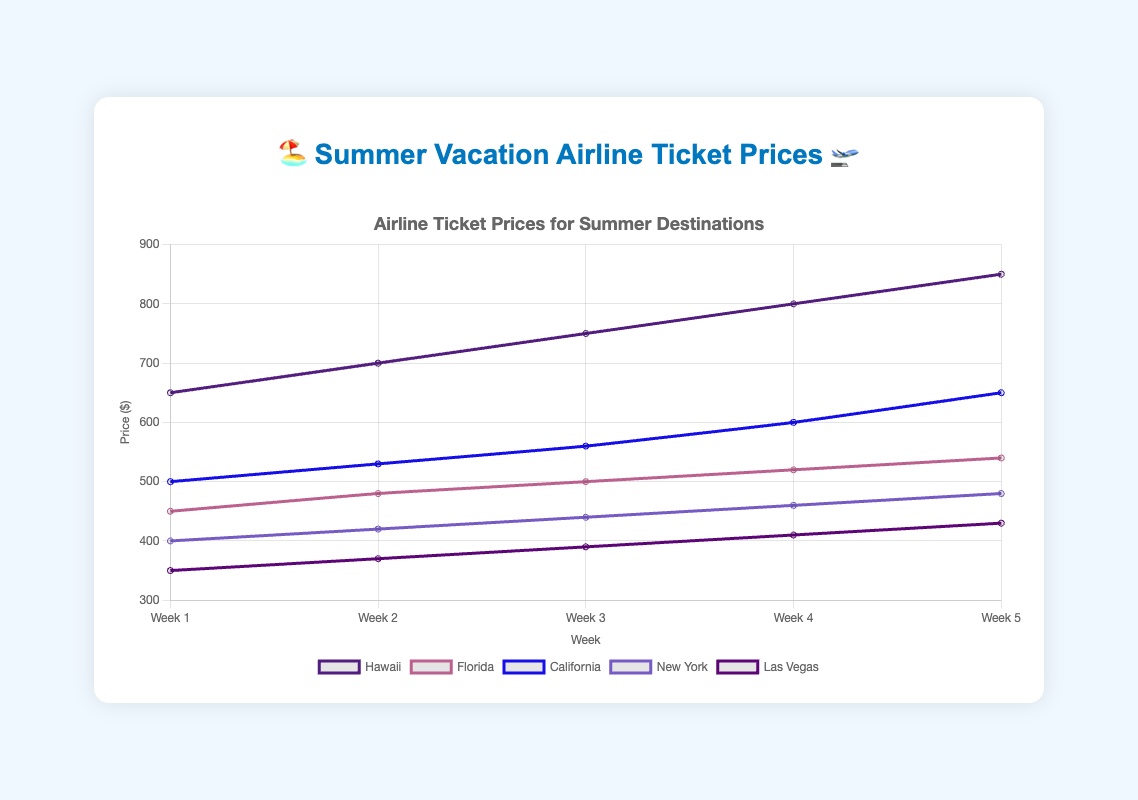What is the starting price for a ticket to Las Vegas in Week 1? The figure shows the price of tickets per week, and the price for Las Vegas in Week 1 is listed at the beginning of its line.
Answer: 350 How does the price of a ticket to Hawaii change from Week 1 to Week 5? Starting from Week 1 to Week 5, examine the line corresponding to Hawaii on the figure. The price increases progressively: Week 1 (650), Week 2 (700), Week 3 (750), Week 4 (800), Week 5 (850).
Answer: Increases Which destination has the highest ticket price in Week 5? Look at the ticket prices for all destinations in Week 5. Compare the values: Hawaii (850), Florida (540), California (650), New York (480), Las Vegas (430).
Answer: Hawaii Compare the difference in price between Florida and California in Week 3. In Week 3, the price for Florida is 500 and for California is 560. The difference is calculated as 560 - 500.
Answer: 60 Which destination has the steepest price increase from Week 1 to Week 5? Calculate the price change for each destination: 
Hawaii (850-650 = 200), Florida (540-450 = 90), California (650-500 = 150), New York (480-400 = 80), Las Vegas (430-350 = 80). Hawaii shows the most significant increase.
Answer: Hawaii Calculate the average price for a ticket to New York over the 5 weeks. Sum the prices for New York (400 + 420 + 440 + 460 + 480) which equals 2200. Divide by the number of weeks (5). 2200 / 5 gives the average price.
Answer: 440 Which two destinations have the closest ticket prices in Week 4? Compare prices for all destinations in Week 4: Hawaii (800), Florida (520), California (600), New York (460), Las Vegas (410). The closest prices are California (600) and Florida (520) with a difference of 80.
Answer: California and Florida What visual cue indicates that ticket prices are increasing for all destinations? Look at the trajectory of the lines representing each destination; all lines are trending upwards from Week 1 to Week 5.
Answer: Upward trending lines How much more expensive are tickets to Hawaii compared to New York in Week 2? Ticket prices in Week 2 for Hawaii (700) and New York (420). Calculate the difference by subtracting: 700 - 420.
Answer: 280 